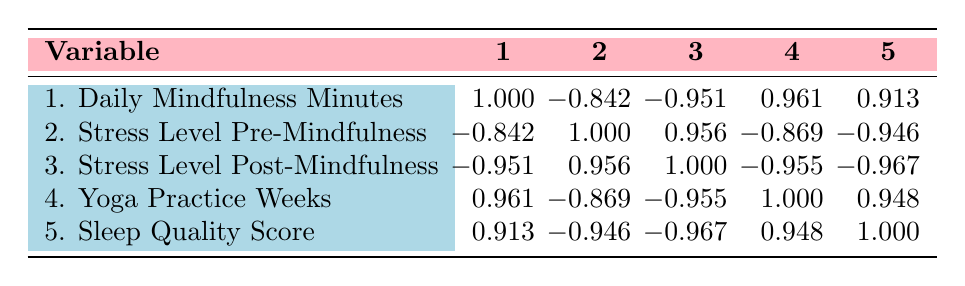What is the correlation between Daily Mindfulness Minutes and Stress Level Pre-Mindfulness? In the table, the correlation coefficient for Daily Mindfulness Minutes (1) and Stress Level Pre-Mindfulness (2) is -0.842. This indicates a strong negative correlation, meaning as daily mindfulness minutes increase, the stress level before mindfulness tends to decrease.
Answer: -0.842 What is the highest correlation value found in the table? The highest correlation value found in the table is 1.000, which corresponds to the correlation between Daily Mindfulness Minutes (1) and itself.
Answer: 1.000 Is the correlation between Sleep Quality Score and Stress Level Post-Mindfulness positive or negative? The correlation between Sleep Quality Score (5) and Stress Level Post-Mindfulness (3) is -0.967, indicating a negative correlation. This means that higher sleep quality is associated with lower stress levels after mindfulness practices.
Answer: Negative What is the sum of the correlations for the Stress Level Pre-Mindfulness and Stress Level Post-Mindfulness? The correlations for Stress Level Pre-Mindfulness (2) and Stress Level Post-Mindfulness (3) are 0.956 and -0.955 respectively. When summed, 0.956 + (-0.955) = 0.001.
Answer: 0.001 How many variables show a negative correlation with Stress Level Pre-Mindfulness? According to the table, Stress Level Pre-Mindfulness (2) has negative correlations with Daily Mindfulness Minutes (-0.842), Yoga Practice Weeks (-0.869), and Sleep Quality Score (-0.946). So, there are three variables.
Answer: 3 What is the average correlation value for the Yoga Practice Weeks variable? The correlation values associated with Yoga Practice Weeks (4) are 0.961 (with Daily Mindfulness Minutes), -0.869 (with Stress Level Pre-Mindfulness), -0.955 (with Stress Level Post-Mindfulness), and 0.948 (with Sleep Quality Score). The average is calculated as (0.961 - 0.869 - 0.955 + 0.948) / 4 = 0.03625.
Answer: 0.03625 Does practicing yoga for more weeks correlate positively with increased daily mindfulness minutes? Yes, the correlation between Yoga Practice Weeks (4) and Daily Mindfulness Minutes (1) is 0.961, indicating a strong positive correlation. This shows that as the weeks of yoga practice increase, so does the duration of daily mindfulness minutes.
Answer: Yes What is the correlation between Yoga Practice Weeks and Sleep Quality Score? The correlation between Yoga Practice Weeks (4) and Sleep Quality Score (5) is 0.948. This indicates a strong positive correlation, meaning more weeks of yoga practice are associated with better sleep quality.
Answer: 0.948 What is the difference between the highest and lowest values for Stress Level Post-Mindfulness correlations? The highest correlation for Stress Level Post-Mindfulness (3) is -0.951 (with Daily Mindfulness Minutes) and the lowest is -0.967 (with Sleep Quality Score). Thus, the difference is -0.951 - (-0.967) = 0.016.
Answer: 0.016 